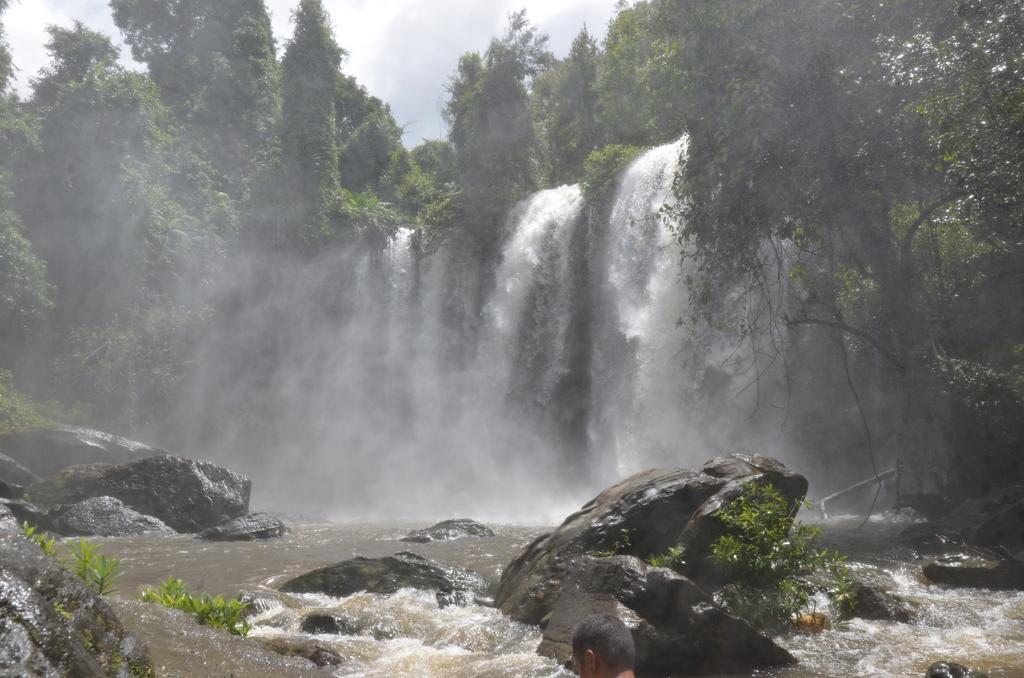Could you give a brief overview of what you see in this image? In this image we can see sky with clouds, trees, creepers, waterfalls and rocks. 